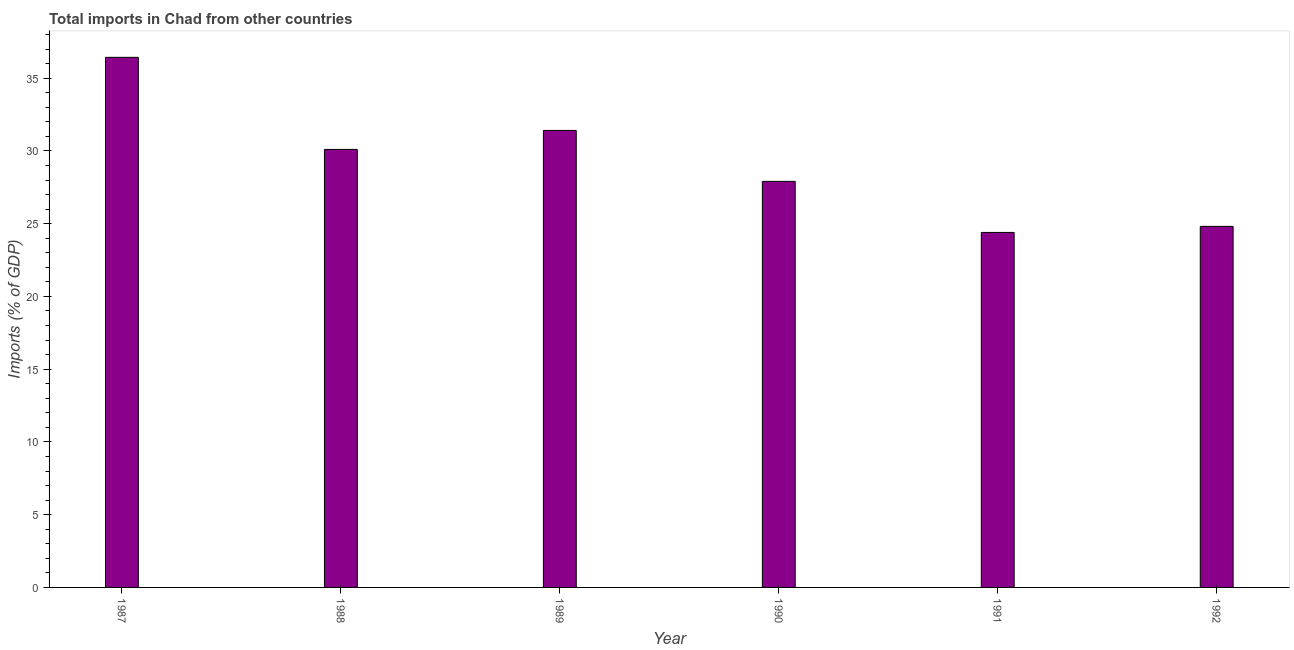Does the graph contain any zero values?
Offer a very short reply. No. What is the title of the graph?
Ensure brevity in your answer.  Total imports in Chad from other countries. What is the label or title of the X-axis?
Provide a succinct answer. Year. What is the label or title of the Y-axis?
Make the answer very short. Imports (% of GDP). What is the total imports in 1991?
Make the answer very short. 24.4. Across all years, what is the maximum total imports?
Your answer should be compact. 36.43. Across all years, what is the minimum total imports?
Provide a short and direct response. 24.4. What is the sum of the total imports?
Make the answer very short. 175.06. What is the difference between the total imports in 1987 and 1989?
Your answer should be very brief. 5.02. What is the average total imports per year?
Make the answer very short. 29.18. What is the median total imports?
Give a very brief answer. 29.01. Do a majority of the years between 1991 and 1988 (inclusive) have total imports greater than 11 %?
Make the answer very short. Yes. Is the total imports in 1988 less than that in 1991?
Provide a succinct answer. No. What is the difference between the highest and the second highest total imports?
Make the answer very short. 5.02. Is the sum of the total imports in 1990 and 1991 greater than the maximum total imports across all years?
Provide a short and direct response. Yes. What is the difference between the highest and the lowest total imports?
Your answer should be compact. 12.03. In how many years, is the total imports greater than the average total imports taken over all years?
Offer a terse response. 3. How many bars are there?
Your response must be concise. 6. What is the Imports (% of GDP) in 1987?
Offer a very short reply. 36.43. What is the Imports (% of GDP) of 1988?
Provide a short and direct response. 30.1. What is the Imports (% of GDP) in 1989?
Provide a short and direct response. 31.41. What is the Imports (% of GDP) in 1990?
Ensure brevity in your answer.  27.91. What is the Imports (% of GDP) in 1991?
Your answer should be compact. 24.4. What is the Imports (% of GDP) in 1992?
Your response must be concise. 24.81. What is the difference between the Imports (% of GDP) in 1987 and 1988?
Ensure brevity in your answer.  6.33. What is the difference between the Imports (% of GDP) in 1987 and 1989?
Your response must be concise. 5.02. What is the difference between the Imports (% of GDP) in 1987 and 1990?
Ensure brevity in your answer.  8.53. What is the difference between the Imports (% of GDP) in 1987 and 1991?
Give a very brief answer. 12.03. What is the difference between the Imports (% of GDP) in 1987 and 1992?
Your answer should be compact. 11.62. What is the difference between the Imports (% of GDP) in 1988 and 1989?
Give a very brief answer. -1.3. What is the difference between the Imports (% of GDP) in 1988 and 1990?
Make the answer very short. 2.2. What is the difference between the Imports (% of GDP) in 1988 and 1991?
Give a very brief answer. 5.71. What is the difference between the Imports (% of GDP) in 1988 and 1992?
Your response must be concise. 5.29. What is the difference between the Imports (% of GDP) in 1989 and 1990?
Provide a short and direct response. 3.5. What is the difference between the Imports (% of GDP) in 1989 and 1991?
Make the answer very short. 7.01. What is the difference between the Imports (% of GDP) in 1989 and 1992?
Your answer should be very brief. 6.59. What is the difference between the Imports (% of GDP) in 1990 and 1991?
Ensure brevity in your answer.  3.51. What is the difference between the Imports (% of GDP) in 1990 and 1992?
Give a very brief answer. 3.09. What is the difference between the Imports (% of GDP) in 1991 and 1992?
Your response must be concise. -0.42. What is the ratio of the Imports (% of GDP) in 1987 to that in 1988?
Your response must be concise. 1.21. What is the ratio of the Imports (% of GDP) in 1987 to that in 1989?
Keep it short and to the point. 1.16. What is the ratio of the Imports (% of GDP) in 1987 to that in 1990?
Your answer should be very brief. 1.31. What is the ratio of the Imports (% of GDP) in 1987 to that in 1991?
Offer a terse response. 1.49. What is the ratio of the Imports (% of GDP) in 1987 to that in 1992?
Keep it short and to the point. 1.47. What is the ratio of the Imports (% of GDP) in 1988 to that in 1989?
Your response must be concise. 0.96. What is the ratio of the Imports (% of GDP) in 1988 to that in 1990?
Ensure brevity in your answer.  1.08. What is the ratio of the Imports (% of GDP) in 1988 to that in 1991?
Provide a succinct answer. 1.23. What is the ratio of the Imports (% of GDP) in 1988 to that in 1992?
Your answer should be compact. 1.21. What is the ratio of the Imports (% of GDP) in 1989 to that in 1990?
Offer a very short reply. 1.12. What is the ratio of the Imports (% of GDP) in 1989 to that in 1991?
Ensure brevity in your answer.  1.29. What is the ratio of the Imports (% of GDP) in 1989 to that in 1992?
Offer a very short reply. 1.27. What is the ratio of the Imports (% of GDP) in 1990 to that in 1991?
Your answer should be very brief. 1.14. 